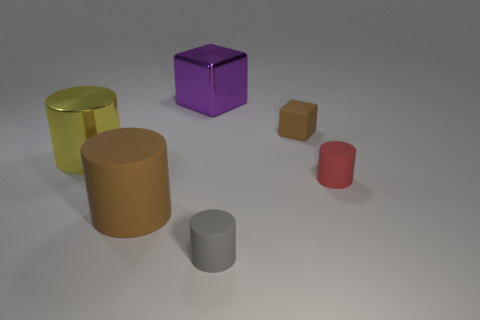Add 1 metallic cylinders. How many objects exist? 7 Subtract all shiny cylinders. How many cylinders are left? 3 Subtract all red cylinders. How many cylinders are left? 3 Subtract all cubes. How many objects are left? 4 Subtract 2 cylinders. How many cylinders are left? 2 Subtract 0 gray spheres. How many objects are left? 6 Subtract all brown blocks. Subtract all red cylinders. How many blocks are left? 1 Subtract all green cylinders. How many purple cubes are left? 1 Subtract all small cyan rubber objects. Subtract all cylinders. How many objects are left? 2 Add 1 brown matte things. How many brown matte things are left? 3 